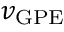Convert formula to latex. <formula><loc_0><loc_0><loc_500><loc_500>v _ { G P E }</formula> 